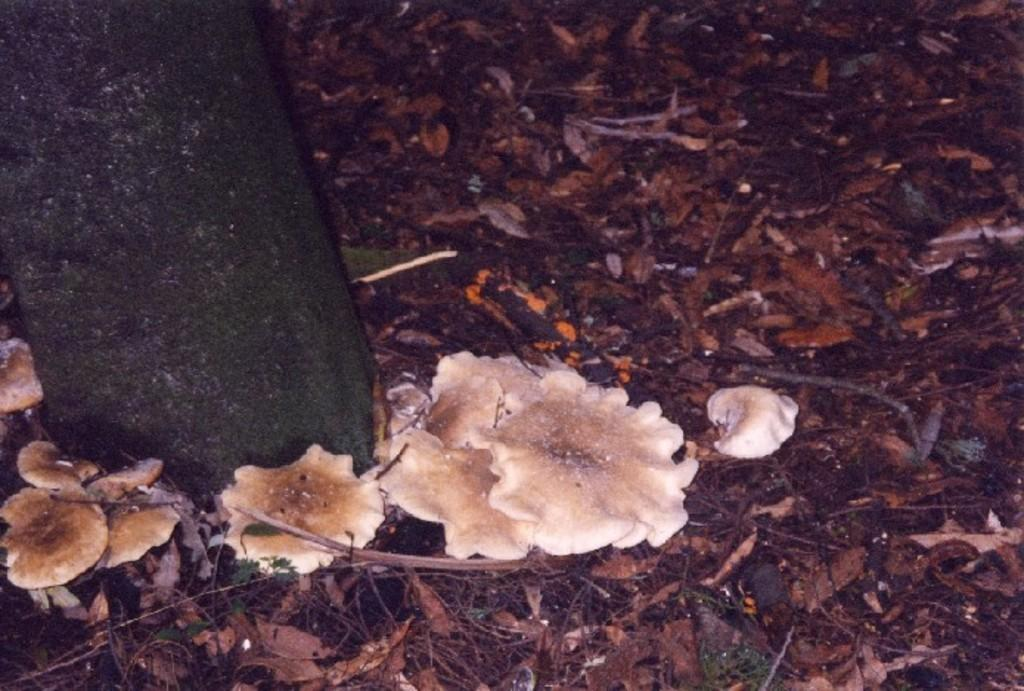What type of vegetation can be seen in the image? There is dry grass in the image. What other natural elements are present in the image? There are mushrooms and a tree trunk in the image. What type of coat is the tree trunk wearing in the image? There is no coat present in the image, as tree trunks do not wear clothing. 